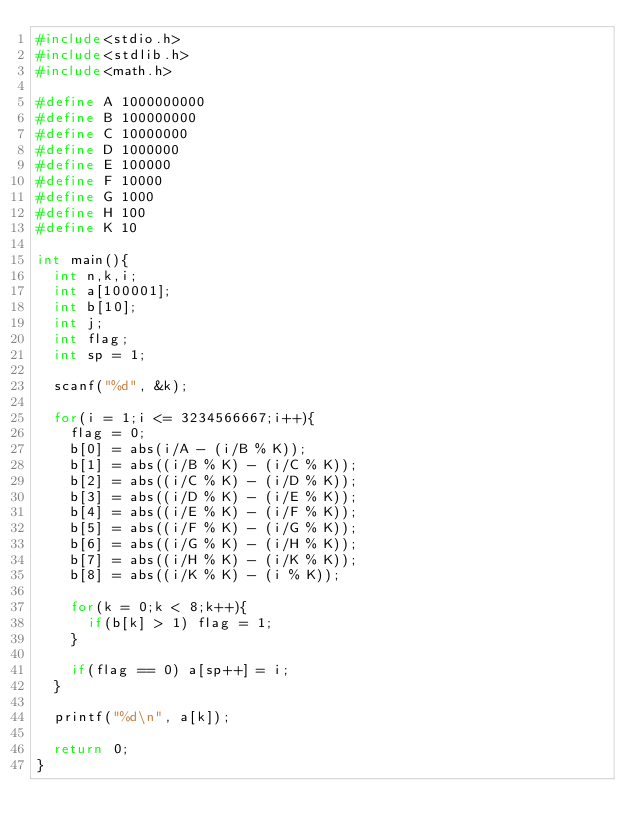<code> <loc_0><loc_0><loc_500><loc_500><_C_>#include<stdio.h>
#include<stdlib.h>
#include<math.h>

#define A 1000000000
#define B 100000000
#define C 10000000
#define D 1000000
#define E 100000
#define F 10000
#define G 1000
#define H 100
#define K 10

int main(){
  int n,k,i;
  int a[100001];
  int b[10];
  int j;
  int flag;
  int sp = 1;

  scanf("%d", &k);

  for(i = 1;i <= 3234566667;i++){
    flag = 0;
    b[0] = abs(i/A - (i/B % K));
    b[1] = abs((i/B % K) - (i/C % K));
    b[2] = abs((i/C % K) - (i/D % K));
    b[3] = abs((i/D % K) - (i/E % K));
    b[4] = abs((i/E % K) - (i/F % K));
    b[5] = abs((i/F % K) - (i/G % K));
    b[6] = abs((i/G % K) - (i/H % K));
    b[7] = abs((i/H % K) - (i/K % K));
    b[8] = abs((i/K % K) - (i % K));

    for(k = 0;k < 8;k++){
      if(b[k] > 1) flag = 1;
    }

    if(flag == 0) a[sp++] = i;
  }

  printf("%d\n", a[k]);

  return 0;
}
</code> 